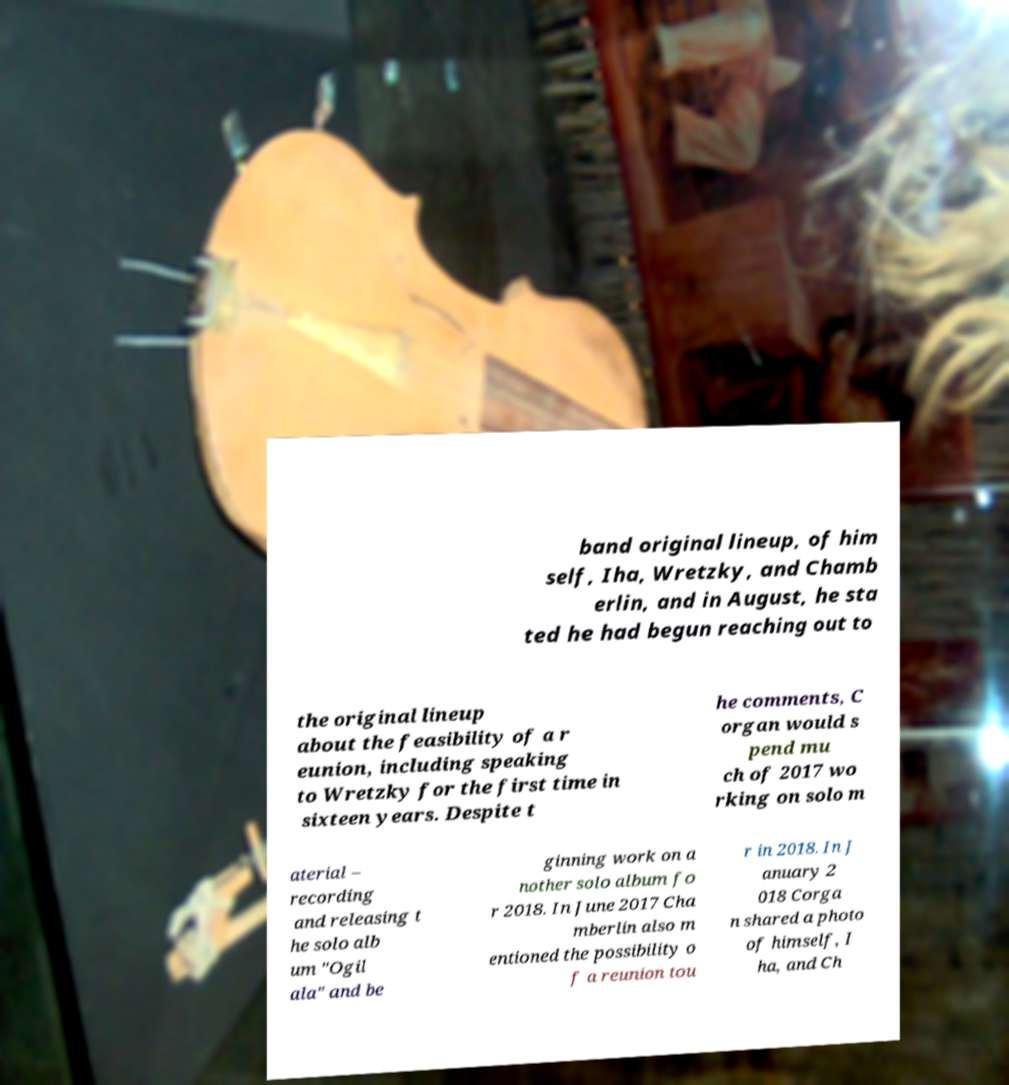Please identify and transcribe the text found in this image. band original lineup, of him self, Iha, Wretzky, and Chamb erlin, and in August, he sta ted he had begun reaching out to the original lineup about the feasibility of a r eunion, including speaking to Wretzky for the first time in sixteen years. Despite t he comments, C organ would s pend mu ch of 2017 wo rking on solo m aterial – recording and releasing t he solo alb um "Ogil ala" and be ginning work on a nother solo album fo r 2018. In June 2017 Cha mberlin also m entioned the possibility o f a reunion tou r in 2018. In J anuary 2 018 Corga n shared a photo of himself, I ha, and Ch 